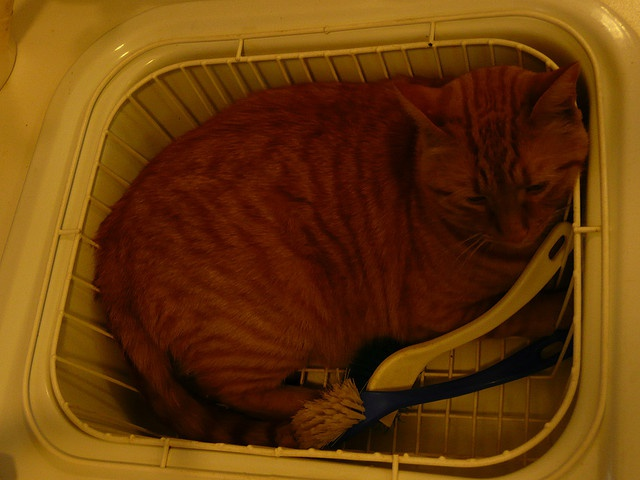Describe the objects in this image and their specific colors. I can see a cat in olive, maroon, and black tones in this image. 